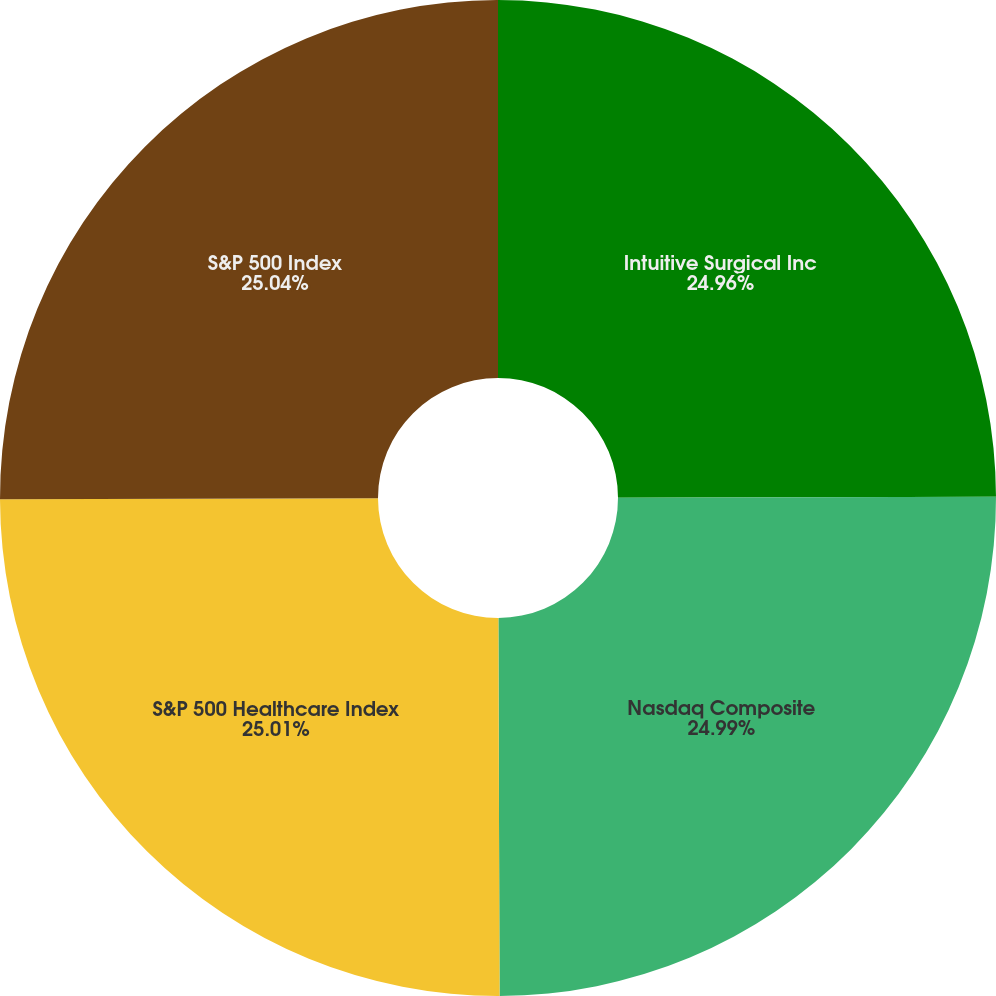Convert chart. <chart><loc_0><loc_0><loc_500><loc_500><pie_chart><fcel>Intuitive Surgical Inc<fcel>Nasdaq Composite<fcel>S&P 500 Healthcare Index<fcel>S&P 500 Index<nl><fcel>24.96%<fcel>24.99%<fcel>25.01%<fcel>25.04%<nl></chart> 